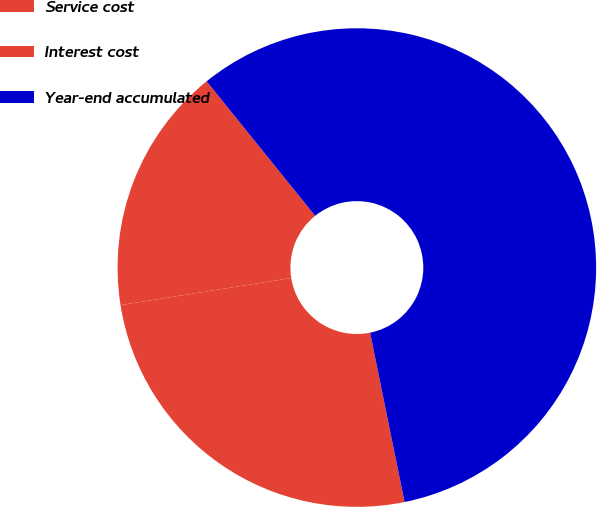<chart> <loc_0><loc_0><loc_500><loc_500><pie_chart><fcel>Service cost<fcel>Interest cost<fcel>Year-end accumulated<nl><fcel>16.71%<fcel>25.69%<fcel>57.61%<nl></chart> 